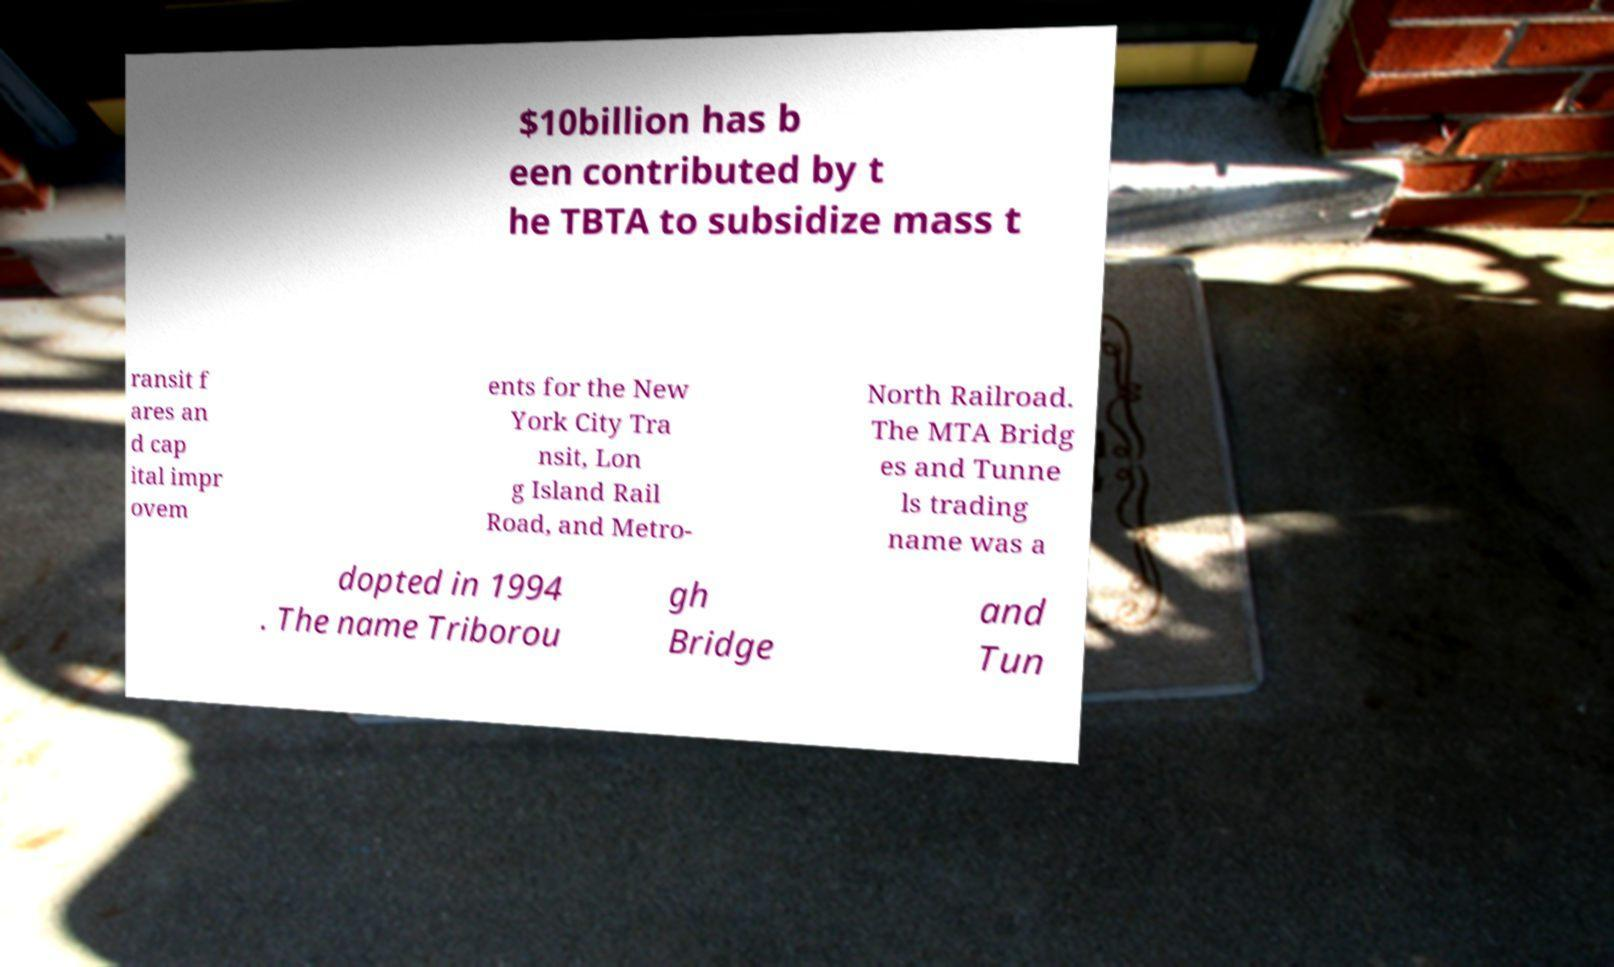Could you assist in decoding the text presented in this image and type it out clearly? $10billion has b een contributed by t he TBTA to subsidize mass t ransit f ares an d cap ital impr ovem ents for the New York City Tra nsit, Lon g Island Rail Road, and Metro- North Railroad. The MTA Bridg es and Tunne ls trading name was a dopted in 1994 . The name Triborou gh Bridge and Tun 